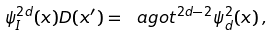Convert formula to latex. <formula><loc_0><loc_0><loc_500><loc_500>\psi _ { I } ^ { 2 d } ( x ) D ( x ^ { \prime } ) = \ a g o t ^ { 2 d - 2 } \psi _ { d } ^ { 2 } ( x ) \, ,</formula> 